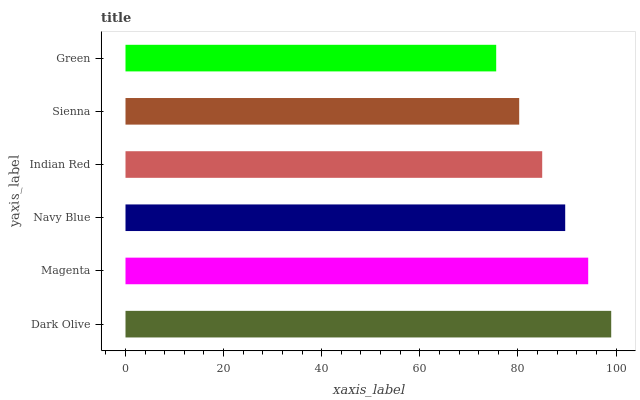Is Green the minimum?
Answer yes or no. Yes. Is Dark Olive the maximum?
Answer yes or no. Yes. Is Magenta the minimum?
Answer yes or no. No. Is Magenta the maximum?
Answer yes or no. No. Is Dark Olive greater than Magenta?
Answer yes or no. Yes. Is Magenta less than Dark Olive?
Answer yes or no. Yes. Is Magenta greater than Dark Olive?
Answer yes or no. No. Is Dark Olive less than Magenta?
Answer yes or no. No. Is Navy Blue the high median?
Answer yes or no. Yes. Is Indian Red the low median?
Answer yes or no. Yes. Is Sienna the high median?
Answer yes or no. No. Is Sienna the low median?
Answer yes or no. No. 